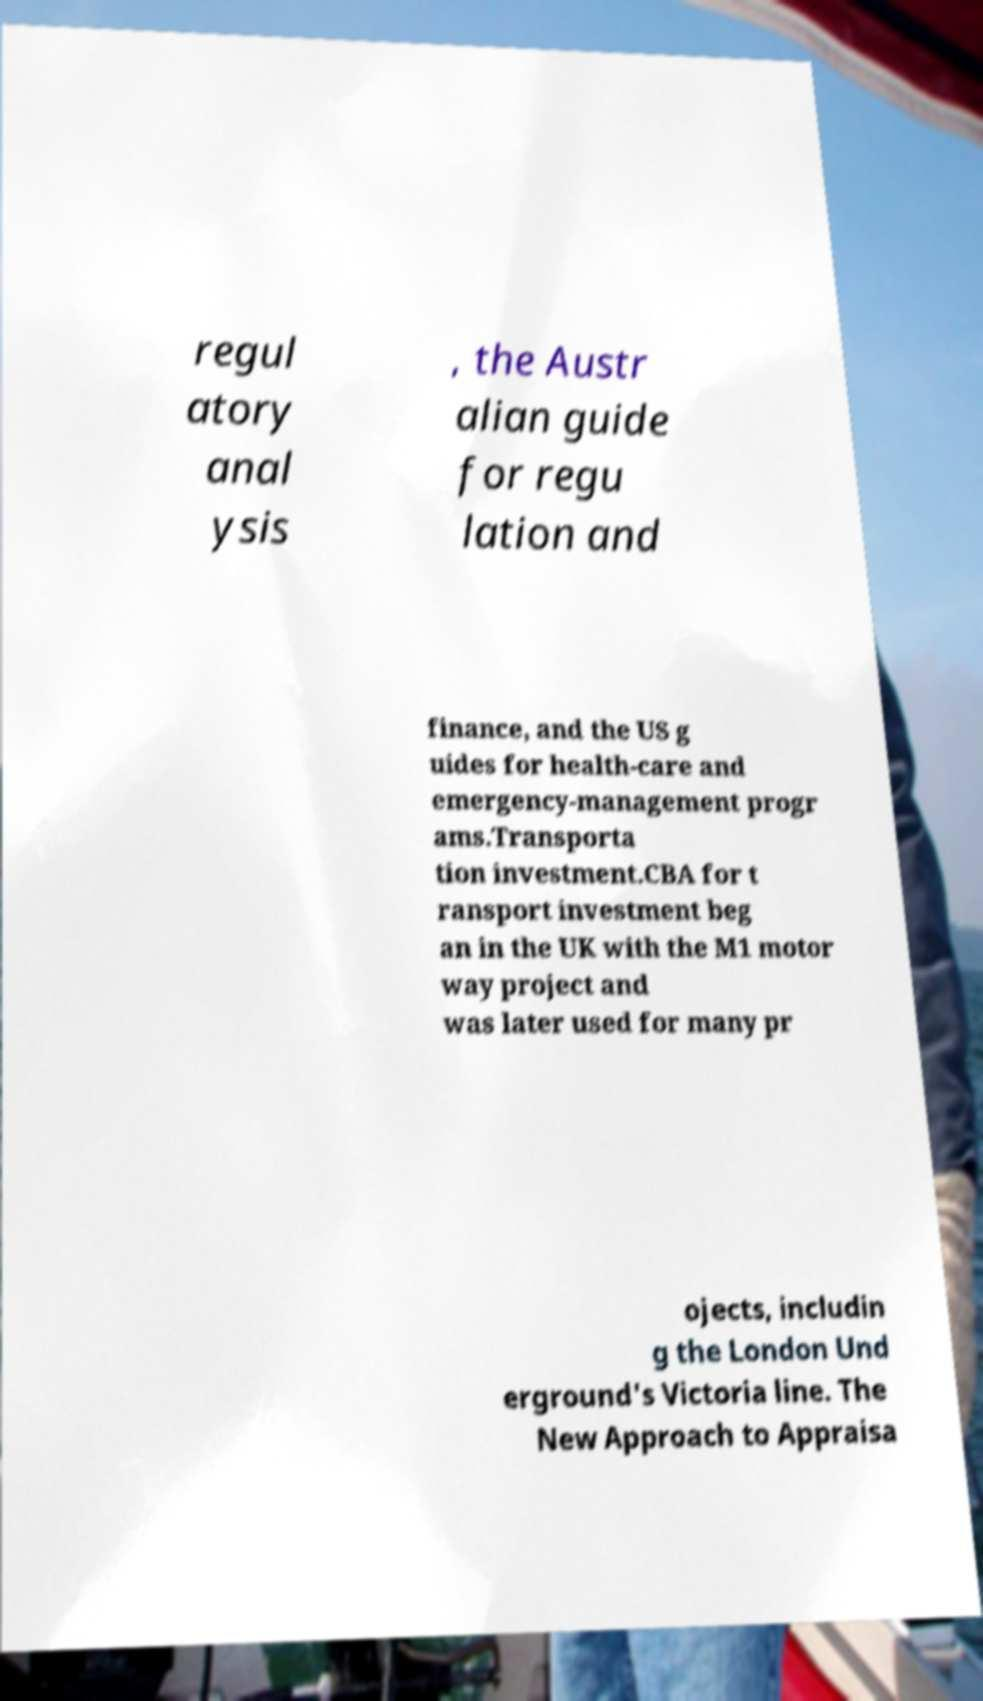Could you extract and type out the text from this image? regul atory anal ysis , the Austr alian guide for regu lation and finance, and the US g uides for health-care and emergency-management progr ams.Transporta tion investment.CBA for t ransport investment beg an in the UK with the M1 motor way project and was later used for many pr ojects, includin g the London Und erground's Victoria line. The New Approach to Appraisa 